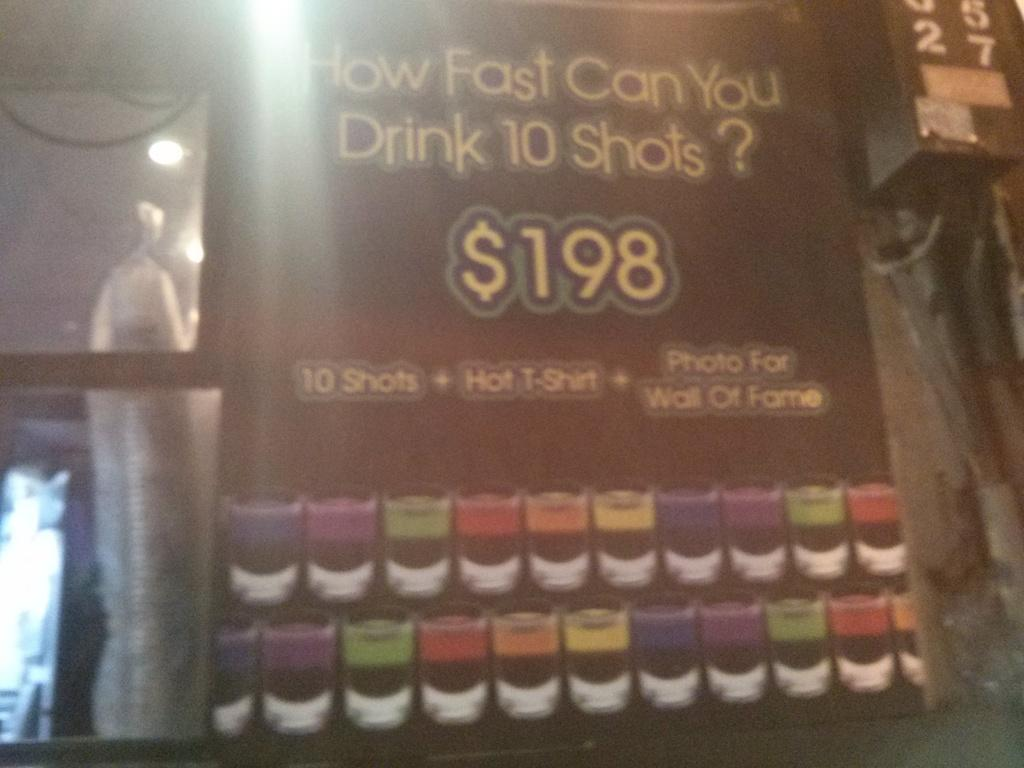Provide a one-sentence caption for the provided image. The cost of the challenge shown here is 198 dollars. 